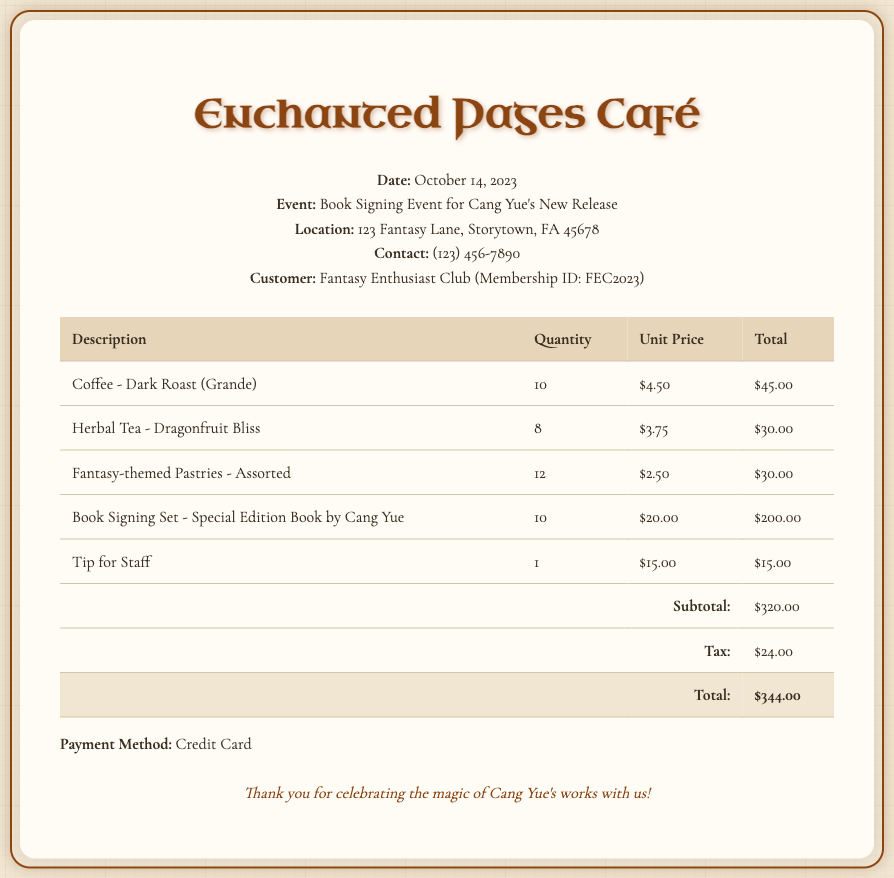What is the date of the transaction? The date of the transaction is specified in the header of the document.
Answer: October 14, 2023 What is the total charge for Coffee? The total charge for Coffee can be found in the breakdown of charges under drinks.
Answer: $45.00 How many Herbal Teas were ordered? The number of Herbal Teas appears under the quantity column specifically for Herbal Tea.
Answer: 8 What is the subtotal before tax? The subtotal is located at the bottom of the charges before tax is added.
Answer: $320.00 What is the total amount after tax? The total amount is the final amount listed after accounting for tax.
Answer: $344.00 What type of event was held at the café? The event type is mentioned in the header section of the document.
Answer: Book Signing Event for Cang Yue's New Release How much was the tip for staff? The tip for staff is listed as a separate charge in the document.
Answer: $15.00 What is the unit price of the Special Edition Book? The unit price for the Special Edition Book is found in the unit price column.
Answer: $20.00 What payment method was used? The payment method is mentioned towards the end of the document.
Answer: Credit Card 